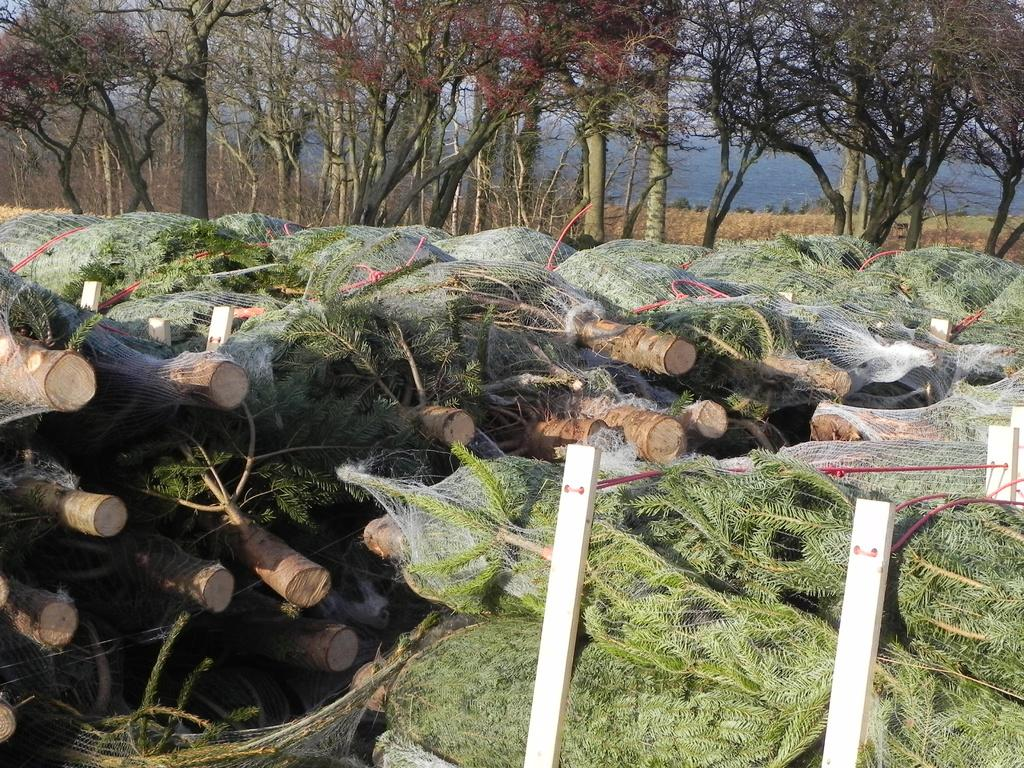What is the main subject of the image? The main subject of the image is huge stacks of logs. Can you describe the setting of the image? In the background of the image, there are trees. What color is the orange in the image? There is no orange present in the image. What hobbies are being practiced in the image? The image does not depict any specific hobbies being practiced. 